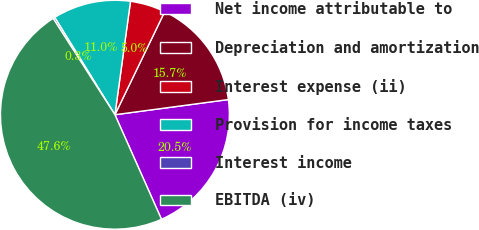Convert chart. <chart><loc_0><loc_0><loc_500><loc_500><pie_chart><fcel>Net income attributable to<fcel>Depreciation and amortization<fcel>Interest expense (ii)<fcel>Provision for income taxes<fcel>Interest income<fcel>EBITDA (iv)<nl><fcel>20.45%<fcel>15.72%<fcel>4.99%<fcel>10.99%<fcel>0.26%<fcel>47.59%<nl></chart> 